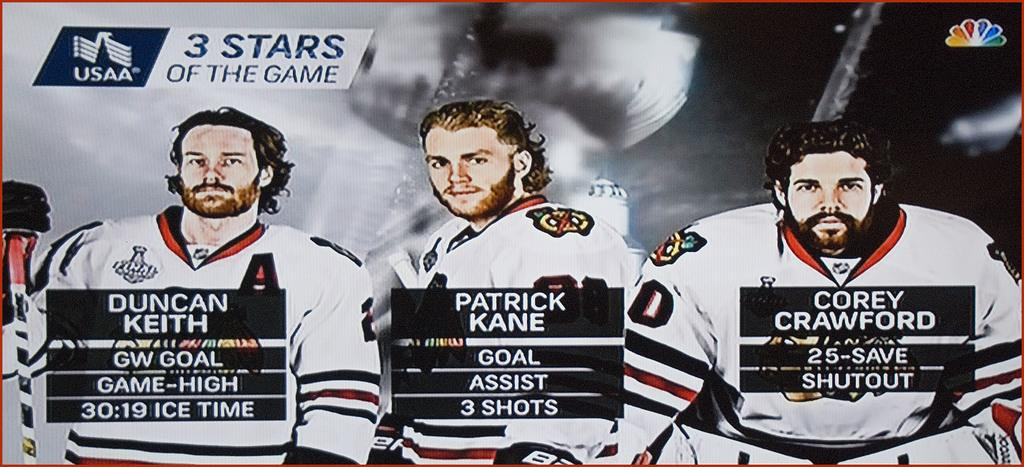<image>
Render a clear and concise summary of the photo. Hockey coverage says that there were three stars of the game. 